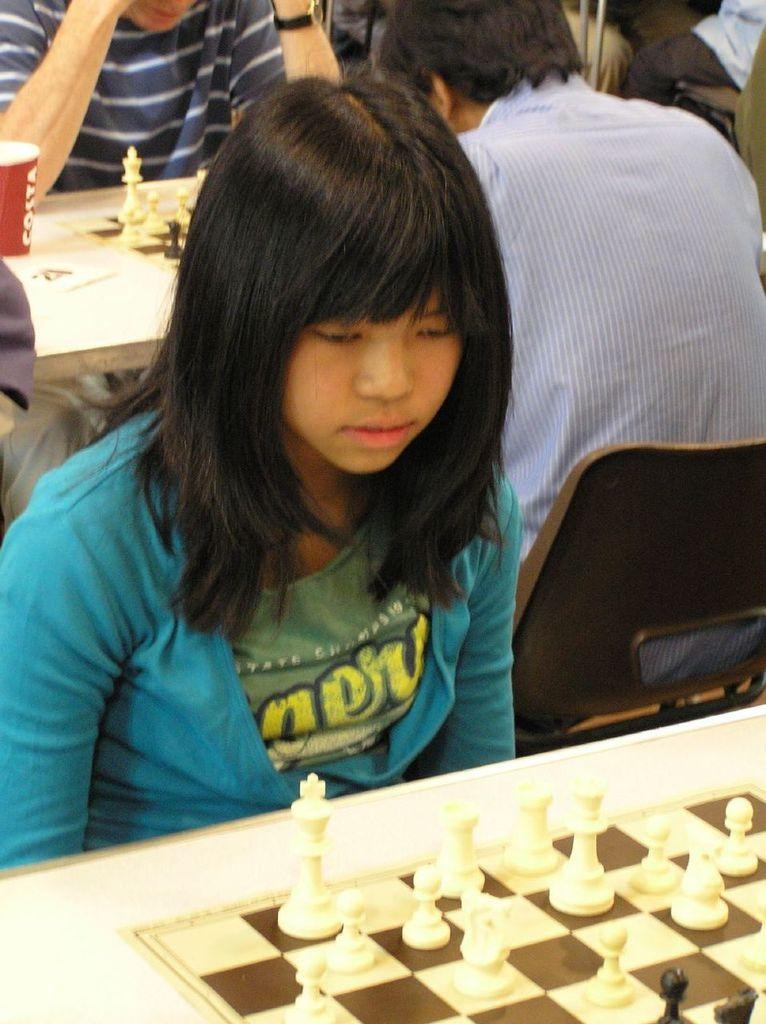What are the people in the image doing? There are people sitting in the image. What object is in front of the people? There is a chess board in front of the people. What year is depicted on the chess board in the image? The image does not show any specific year on the chess board. How many clocks are visible on the chess board in the image? There are no clocks visible on the chess board in the image. 